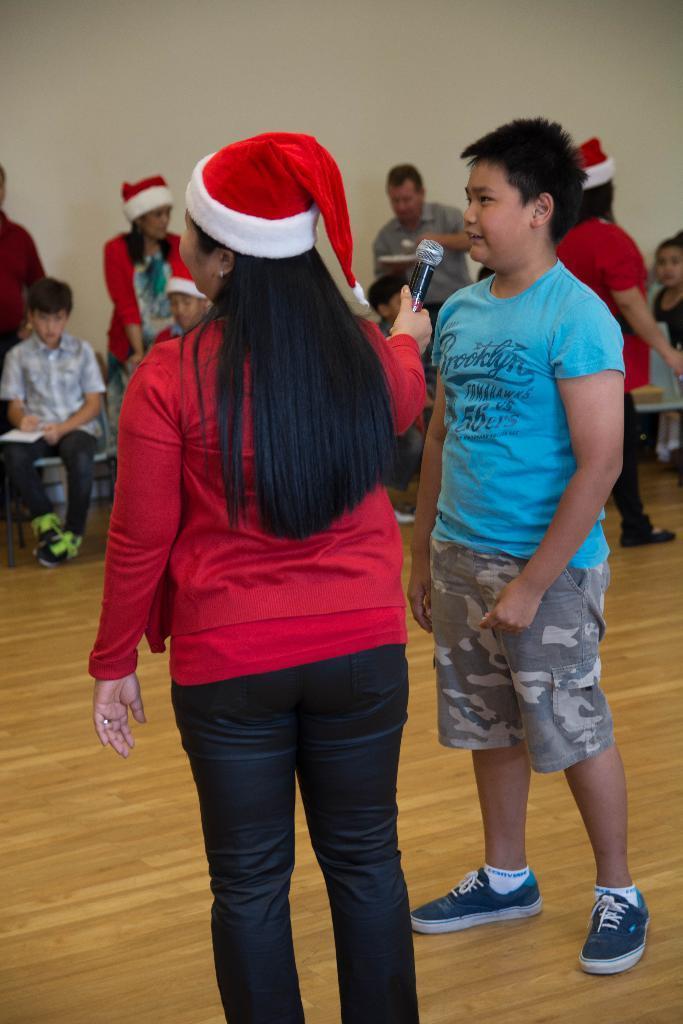In one or two sentences, can you explain what this image depicts? In this image there are two people standing on the floor. The woman to the left is holding a microphone in her hand. In front of them there are people sitting on the chairs. Behind them there is a wall. They all are wearing Santa Claus caps. 